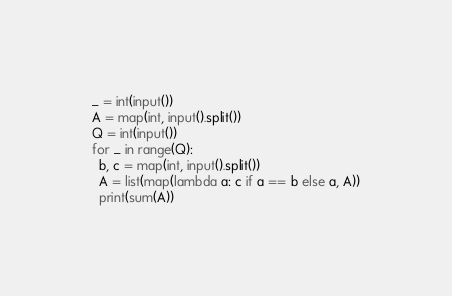Convert code to text. <code><loc_0><loc_0><loc_500><loc_500><_Python_>_ = int(input())
A = map(int, input().split())
Q = int(input())
for _ in range(Q):
  b, c = map(int, input().split())
  A = list(map(lambda a: c if a == b else a, A))
  print(sum(A))</code> 